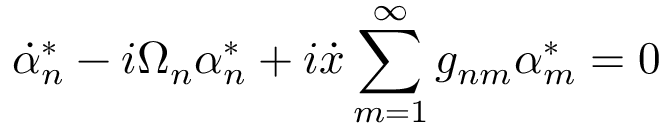Convert formula to latex. <formula><loc_0><loc_0><loc_500><loc_500>\dot { \alpha } _ { n } ^ { * } - i \Omega _ { n } \alpha _ { n } ^ { * } + i \dot { x } \sum _ { m = 1 } ^ { \infty } g _ { n m } \alpha _ { m } ^ { * } = 0</formula> 